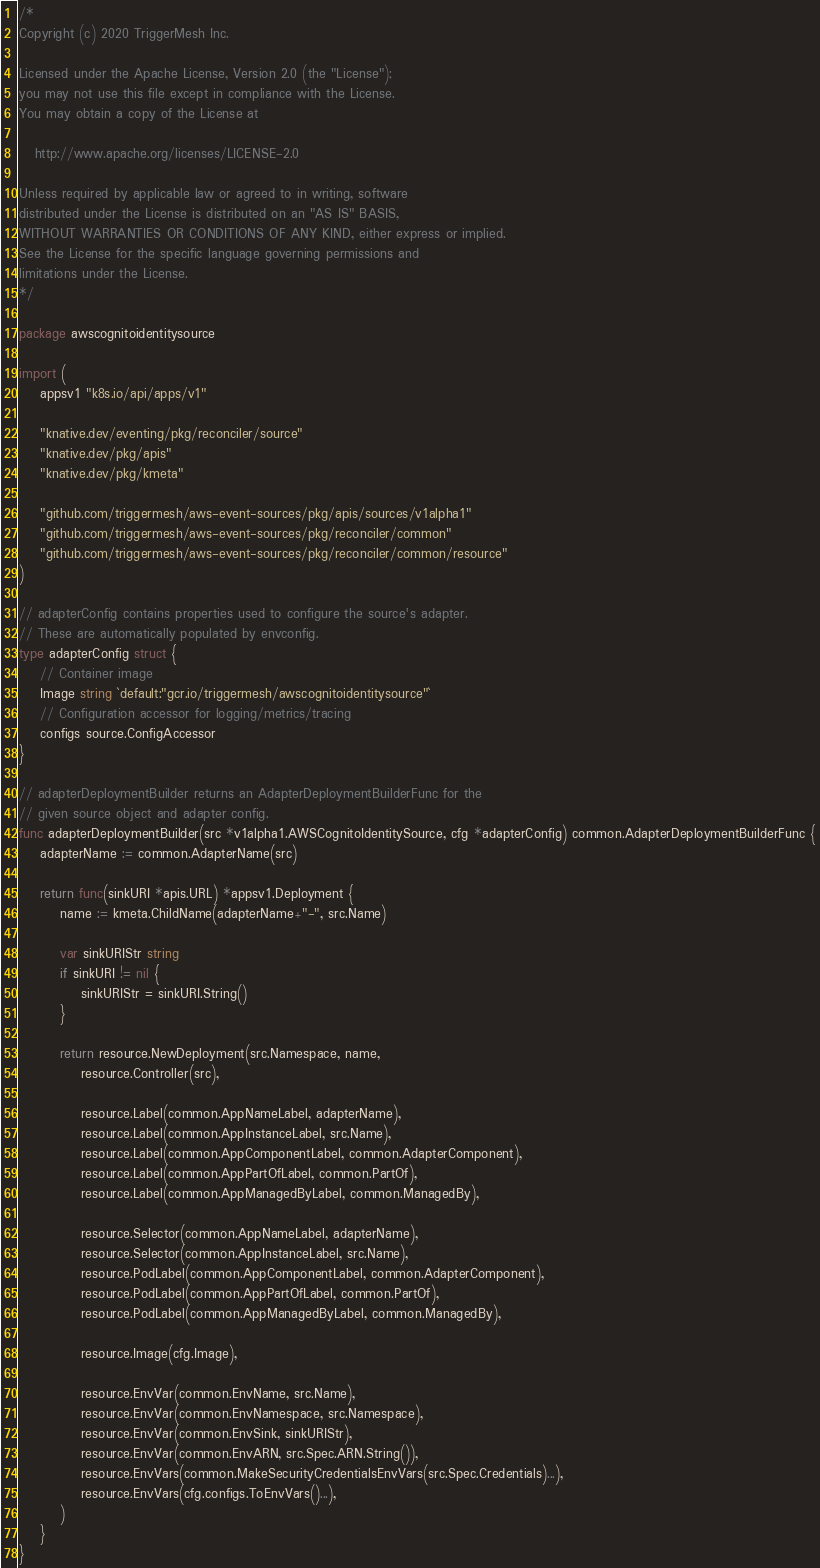<code> <loc_0><loc_0><loc_500><loc_500><_Go_>/*
Copyright (c) 2020 TriggerMesh Inc.

Licensed under the Apache License, Version 2.0 (the "License");
you may not use this file except in compliance with the License.
You may obtain a copy of the License at

   http://www.apache.org/licenses/LICENSE-2.0

Unless required by applicable law or agreed to in writing, software
distributed under the License is distributed on an "AS IS" BASIS,
WITHOUT WARRANTIES OR CONDITIONS OF ANY KIND, either express or implied.
See the License for the specific language governing permissions and
limitations under the License.
*/

package awscognitoidentitysource

import (
	appsv1 "k8s.io/api/apps/v1"

	"knative.dev/eventing/pkg/reconciler/source"
	"knative.dev/pkg/apis"
	"knative.dev/pkg/kmeta"

	"github.com/triggermesh/aws-event-sources/pkg/apis/sources/v1alpha1"
	"github.com/triggermesh/aws-event-sources/pkg/reconciler/common"
	"github.com/triggermesh/aws-event-sources/pkg/reconciler/common/resource"
)

// adapterConfig contains properties used to configure the source's adapter.
// These are automatically populated by envconfig.
type adapterConfig struct {
	// Container image
	Image string `default:"gcr.io/triggermesh/awscognitoidentitysource"`
	// Configuration accessor for logging/metrics/tracing
	configs source.ConfigAccessor
}

// adapterDeploymentBuilder returns an AdapterDeploymentBuilderFunc for the
// given source object and adapter config.
func adapterDeploymentBuilder(src *v1alpha1.AWSCognitoIdentitySource, cfg *adapterConfig) common.AdapterDeploymentBuilderFunc {
	adapterName := common.AdapterName(src)

	return func(sinkURI *apis.URL) *appsv1.Deployment {
		name := kmeta.ChildName(adapterName+"-", src.Name)

		var sinkURIStr string
		if sinkURI != nil {
			sinkURIStr = sinkURI.String()
		}

		return resource.NewDeployment(src.Namespace, name,
			resource.Controller(src),

			resource.Label(common.AppNameLabel, adapterName),
			resource.Label(common.AppInstanceLabel, src.Name),
			resource.Label(common.AppComponentLabel, common.AdapterComponent),
			resource.Label(common.AppPartOfLabel, common.PartOf),
			resource.Label(common.AppManagedByLabel, common.ManagedBy),

			resource.Selector(common.AppNameLabel, adapterName),
			resource.Selector(common.AppInstanceLabel, src.Name),
			resource.PodLabel(common.AppComponentLabel, common.AdapterComponent),
			resource.PodLabel(common.AppPartOfLabel, common.PartOf),
			resource.PodLabel(common.AppManagedByLabel, common.ManagedBy),

			resource.Image(cfg.Image),

			resource.EnvVar(common.EnvName, src.Name),
			resource.EnvVar(common.EnvNamespace, src.Namespace),
			resource.EnvVar(common.EnvSink, sinkURIStr),
			resource.EnvVar(common.EnvARN, src.Spec.ARN.String()),
			resource.EnvVars(common.MakeSecurityCredentialsEnvVars(src.Spec.Credentials)...),
			resource.EnvVars(cfg.configs.ToEnvVars()...),
		)
	}
}
</code> 